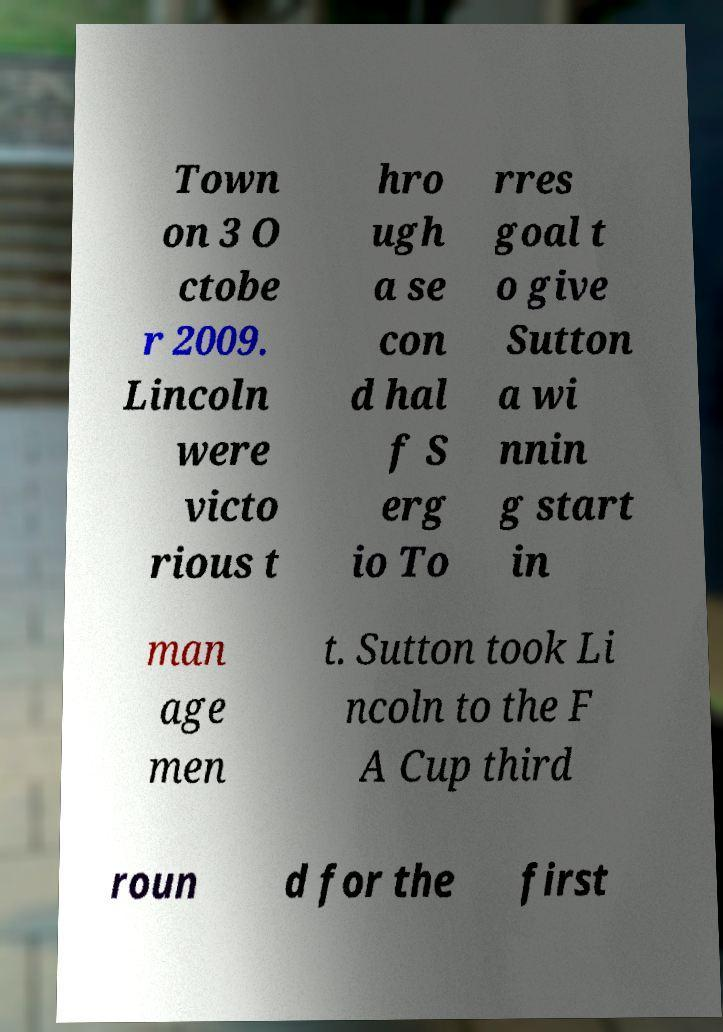What messages or text are displayed in this image? I need them in a readable, typed format. Town on 3 O ctobe r 2009. Lincoln were victo rious t hro ugh a se con d hal f S erg io To rres goal t o give Sutton a wi nnin g start in man age men t. Sutton took Li ncoln to the F A Cup third roun d for the first 